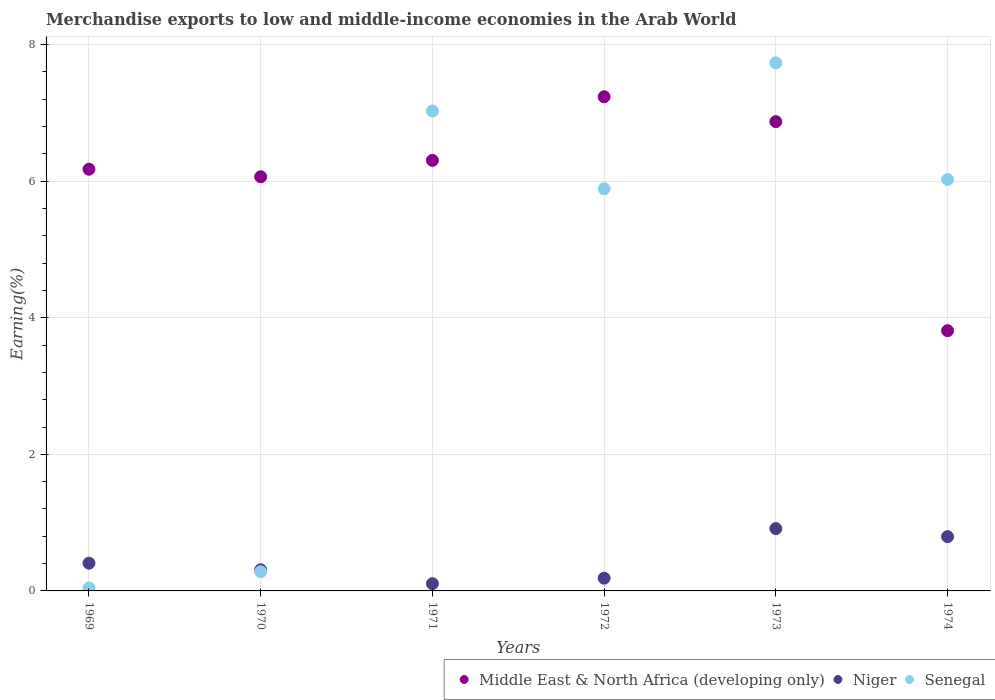What is the percentage of amount earned from merchandise exports in Niger in 1969?
Your response must be concise. 0.41. Across all years, what is the maximum percentage of amount earned from merchandise exports in Senegal?
Your answer should be compact. 7.73. Across all years, what is the minimum percentage of amount earned from merchandise exports in Niger?
Your answer should be very brief. 0.11. In which year was the percentage of amount earned from merchandise exports in Middle East & North Africa (developing only) minimum?
Provide a short and direct response. 1974. What is the total percentage of amount earned from merchandise exports in Senegal in the graph?
Your answer should be compact. 27. What is the difference between the percentage of amount earned from merchandise exports in Niger in 1969 and that in 1973?
Your response must be concise. -0.51. What is the difference between the percentage of amount earned from merchandise exports in Niger in 1972 and the percentage of amount earned from merchandise exports in Senegal in 1970?
Your answer should be very brief. -0.09. What is the average percentage of amount earned from merchandise exports in Middle East & North Africa (developing only) per year?
Provide a short and direct response. 6.08. In the year 1971, what is the difference between the percentage of amount earned from merchandise exports in Senegal and percentage of amount earned from merchandise exports in Niger?
Ensure brevity in your answer.  6.92. What is the ratio of the percentage of amount earned from merchandise exports in Senegal in 1970 to that in 1974?
Offer a very short reply. 0.05. Is the percentage of amount earned from merchandise exports in Senegal in 1970 less than that in 1974?
Keep it short and to the point. Yes. What is the difference between the highest and the second highest percentage of amount earned from merchandise exports in Senegal?
Offer a terse response. 0.71. What is the difference between the highest and the lowest percentage of amount earned from merchandise exports in Middle East & North Africa (developing only)?
Keep it short and to the point. 3.43. Is it the case that in every year, the sum of the percentage of amount earned from merchandise exports in Niger and percentage of amount earned from merchandise exports in Middle East & North Africa (developing only)  is greater than the percentage of amount earned from merchandise exports in Senegal?
Provide a succinct answer. No. Is the percentage of amount earned from merchandise exports in Senegal strictly less than the percentage of amount earned from merchandise exports in Niger over the years?
Ensure brevity in your answer.  No. What is the difference between two consecutive major ticks on the Y-axis?
Provide a succinct answer. 2. Where does the legend appear in the graph?
Ensure brevity in your answer.  Bottom right. How many legend labels are there?
Ensure brevity in your answer.  3. How are the legend labels stacked?
Keep it short and to the point. Horizontal. What is the title of the graph?
Your answer should be very brief. Merchandise exports to low and middle-income economies in the Arab World. Does "Moldova" appear as one of the legend labels in the graph?
Provide a succinct answer. No. What is the label or title of the Y-axis?
Provide a succinct answer. Earning(%). What is the Earning(%) of Middle East & North Africa (developing only) in 1969?
Provide a succinct answer. 6.18. What is the Earning(%) in Niger in 1969?
Ensure brevity in your answer.  0.41. What is the Earning(%) of Senegal in 1969?
Your response must be concise. 0.04. What is the Earning(%) of Middle East & North Africa (developing only) in 1970?
Offer a terse response. 6.06. What is the Earning(%) in Niger in 1970?
Provide a succinct answer. 0.31. What is the Earning(%) of Senegal in 1970?
Your answer should be very brief. 0.28. What is the Earning(%) in Middle East & North Africa (developing only) in 1971?
Provide a succinct answer. 6.3. What is the Earning(%) of Niger in 1971?
Offer a very short reply. 0.11. What is the Earning(%) of Senegal in 1971?
Offer a terse response. 7.03. What is the Earning(%) of Middle East & North Africa (developing only) in 1972?
Make the answer very short. 7.24. What is the Earning(%) in Niger in 1972?
Make the answer very short. 0.19. What is the Earning(%) in Senegal in 1972?
Provide a short and direct response. 5.89. What is the Earning(%) in Middle East & North Africa (developing only) in 1973?
Give a very brief answer. 6.87. What is the Earning(%) of Niger in 1973?
Your answer should be compact. 0.91. What is the Earning(%) of Senegal in 1973?
Give a very brief answer. 7.73. What is the Earning(%) in Middle East & North Africa (developing only) in 1974?
Offer a terse response. 3.81. What is the Earning(%) of Niger in 1974?
Your answer should be compact. 0.79. What is the Earning(%) in Senegal in 1974?
Make the answer very short. 6.02. Across all years, what is the maximum Earning(%) in Middle East & North Africa (developing only)?
Your answer should be very brief. 7.24. Across all years, what is the maximum Earning(%) in Niger?
Keep it short and to the point. 0.91. Across all years, what is the maximum Earning(%) in Senegal?
Provide a succinct answer. 7.73. Across all years, what is the minimum Earning(%) in Middle East & North Africa (developing only)?
Offer a terse response. 3.81. Across all years, what is the minimum Earning(%) of Niger?
Your response must be concise. 0.11. Across all years, what is the minimum Earning(%) of Senegal?
Make the answer very short. 0.04. What is the total Earning(%) of Middle East & North Africa (developing only) in the graph?
Your answer should be very brief. 36.46. What is the total Earning(%) of Niger in the graph?
Keep it short and to the point. 2.72. What is the total Earning(%) of Senegal in the graph?
Ensure brevity in your answer.  27. What is the difference between the Earning(%) of Middle East & North Africa (developing only) in 1969 and that in 1970?
Offer a terse response. 0.11. What is the difference between the Earning(%) in Niger in 1969 and that in 1970?
Offer a very short reply. 0.1. What is the difference between the Earning(%) of Senegal in 1969 and that in 1970?
Provide a succinct answer. -0.24. What is the difference between the Earning(%) of Middle East & North Africa (developing only) in 1969 and that in 1971?
Give a very brief answer. -0.13. What is the difference between the Earning(%) of Niger in 1969 and that in 1971?
Your answer should be compact. 0.3. What is the difference between the Earning(%) in Senegal in 1969 and that in 1971?
Make the answer very short. -6.98. What is the difference between the Earning(%) of Middle East & North Africa (developing only) in 1969 and that in 1972?
Your response must be concise. -1.06. What is the difference between the Earning(%) in Niger in 1969 and that in 1972?
Offer a terse response. 0.22. What is the difference between the Earning(%) of Senegal in 1969 and that in 1972?
Offer a very short reply. -5.85. What is the difference between the Earning(%) in Middle East & North Africa (developing only) in 1969 and that in 1973?
Ensure brevity in your answer.  -0.7. What is the difference between the Earning(%) in Niger in 1969 and that in 1973?
Provide a succinct answer. -0.51. What is the difference between the Earning(%) of Senegal in 1969 and that in 1973?
Make the answer very short. -7.69. What is the difference between the Earning(%) of Middle East & North Africa (developing only) in 1969 and that in 1974?
Provide a succinct answer. 2.36. What is the difference between the Earning(%) in Niger in 1969 and that in 1974?
Provide a succinct answer. -0.39. What is the difference between the Earning(%) in Senegal in 1969 and that in 1974?
Your response must be concise. -5.98. What is the difference between the Earning(%) of Middle East & North Africa (developing only) in 1970 and that in 1971?
Provide a short and direct response. -0.24. What is the difference between the Earning(%) in Niger in 1970 and that in 1971?
Offer a very short reply. 0.2. What is the difference between the Earning(%) of Senegal in 1970 and that in 1971?
Ensure brevity in your answer.  -6.75. What is the difference between the Earning(%) in Middle East & North Africa (developing only) in 1970 and that in 1972?
Offer a very short reply. -1.17. What is the difference between the Earning(%) in Niger in 1970 and that in 1972?
Your answer should be very brief. 0.12. What is the difference between the Earning(%) in Senegal in 1970 and that in 1972?
Offer a very short reply. -5.61. What is the difference between the Earning(%) in Middle East & North Africa (developing only) in 1970 and that in 1973?
Give a very brief answer. -0.81. What is the difference between the Earning(%) of Niger in 1970 and that in 1973?
Provide a short and direct response. -0.6. What is the difference between the Earning(%) in Senegal in 1970 and that in 1973?
Your answer should be compact. -7.45. What is the difference between the Earning(%) of Middle East & North Africa (developing only) in 1970 and that in 1974?
Ensure brevity in your answer.  2.25. What is the difference between the Earning(%) of Niger in 1970 and that in 1974?
Offer a very short reply. -0.48. What is the difference between the Earning(%) in Senegal in 1970 and that in 1974?
Provide a succinct answer. -5.74. What is the difference between the Earning(%) of Middle East & North Africa (developing only) in 1971 and that in 1972?
Offer a very short reply. -0.93. What is the difference between the Earning(%) in Niger in 1971 and that in 1972?
Your answer should be very brief. -0.08. What is the difference between the Earning(%) of Senegal in 1971 and that in 1972?
Provide a short and direct response. 1.14. What is the difference between the Earning(%) of Middle East & North Africa (developing only) in 1971 and that in 1973?
Provide a short and direct response. -0.57. What is the difference between the Earning(%) in Niger in 1971 and that in 1973?
Make the answer very short. -0.81. What is the difference between the Earning(%) of Senegal in 1971 and that in 1973?
Make the answer very short. -0.71. What is the difference between the Earning(%) in Middle East & North Africa (developing only) in 1971 and that in 1974?
Provide a short and direct response. 2.49. What is the difference between the Earning(%) of Niger in 1971 and that in 1974?
Keep it short and to the point. -0.69. What is the difference between the Earning(%) of Middle East & North Africa (developing only) in 1972 and that in 1973?
Provide a short and direct response. 0.36. What is the difference between the Earning(%) in Niger in 1972 and that in 1973?
Provide a succinct answer. -0.73. What is the difference between the Earning(%) in Senegal in 1972 and that in 1973?
Ensure brevity in your answer.  -1.84. What is the difference between the Earning(%) in Middle East & North Africa (developing only) in 1972 and that in 1974?
Your answer should be very brief. 3.43. What is the difference between the Earning(%) in Niger in 1972 and that in 1974?
Keep it short and to the point. -0.61. What is the difference between the Earning(%) of Senegal in 1972 and that in 1974?
Provide a succinct answer. -0.14. What is the difference between the Earning(%) in Middle East & North Africa (developing only) in 1973 and that in 1974?
Keep it short and to the point. 3.06. What is the difference between the Earning(%) of Niger in 1973 and that in 1974?
Provide a short and direct response. 0.12. What is the difference between the Earning(%) of Senegal in 1973 and that in 1974?
Your response must be concise. 1.71. What is the difference between the Earning(%) in Middle East & North Africa (developing only) in 1969 and the Earning(%) in Niger in 1970?
Give a very brief answer. 5.87. What is the difference between the Earning(%) in Middle East & North Africa (developing only) in 1969 and the Earning(%) in Senegal in 1970?
Provide a succinct answer. 5.89. What is the difference between the Earning(%) of Niger in 1969 and the Earning(%) of Senegal in 1970?
Provide a succinct answer. 0.13. What is the difference between the Earning(%) of Middle East & North Africa (developing only) in 1969 and the Earning(%) of Niger in 1971?
Keep it short and to the point. 6.07. What is the difference between the Earning(%) of Middle East & North Africa (developing only) in 1969 and the Earning(%) of Senegal in 1971?
Offer a very short reply. -0.85. What is the difference between the Earning(%) in Niger in 1969 and the Earning(%) in Senegal in 1971?
Your answer should be very brief. -6.62. What is the difference between the Earning(%) of Middle East & North Africa (developing only) in 1969 and the Earning(%) of Niger in 1972?
Provide a succinct answer. 5.99. What is the difference between the Earning(%) in Middle East & North Africa (developing only) in 1969 and the Earning(%) in Senegal in 1972?
Provide a succinct answer. 0.29. What is the difference between the Earning(%) of Niger in 1969 and the Earning(%) of Senegal in 1972?
Offer a very short reply. -5.48. What is the difference between the Earning(%) of Middle East & North Africa (developing only) in 1969 and the Earning(%) of Niger in 1973?
Your answer should be compact. 5.26. What is the difference between the Earning(%) in Middle East & North Africa (developing only) in 1969 and the Earning(%) in Senegal in 1973?
Your response must be concise. -1.56. What is the difference between the Earning(%) of Niger in 1969 and the Earning(%) of Senegal in 1973?
Your response must be concise. -7.33. What is the difference between the Earning(%) of Middle East & North Africa (developing only) in 1969 and the Earning(%) of Niger in 1974?
Offer a very short reply. 5.38. What is the difference between the Earning(%) of Middle East & North Africa (developing only) in 1969 and the Earning(%) of Senegal in 1974?
Keep it short and to the point. 0.15. What is the difference between the Earning(%) of Niger in 1969 and the Earning(%) of Senegal in 1974?
Keep it short and to the point. -5.62. What is the difference between the Earning(%) in Middle East & North Africa (developing only) in 1970 and the Earning(%) in Niger in 1971?
Your response must be concise. 5.96. What is the difference between the Earning(%) in Middle East & North Africa (developing only) in 1970 and the Earning(%) in Senegal in 1971?
Provide a short and direct response. -0.96. What is the difference between the Earning(%) of Niger in 1970 and the Earning(%) of Senegal in 1971?
Provide a succinct answer. -6.72. What is the difference between the Earning(%) of Middle East & North Africa (developing only) in 1970 and the Earning(%) of Niger in 1972?
Offer a terse response. 5.88. What is the difference between the Earning(%) of Middle East & North Africa (developing only) in 1970 and the Earning(%) of Senegal in 1972?
Give a very brief answer. 0.18. What is the difference between the Earning(%) in Niger in 1970 and the Earning(%) in Senegal in 1972?
Your response must be concise. -5.58. What is the difference between the Earning(%) in Middle East & North Africa (developing only) in 1970 and the Earning(%) in Niger in 1973?
Keep it short and to the point. 5.15. What is the difference between the Earning(%) in Middle East & North Africa (developing only) in 1970 and the Earning(%) in Senegal in 1973?
Your answer should be compact. -1.67. What is the difference between the Earning(%) of Niger in 1970 and the Earning(%) of Senegal in 1973?
Give a very brief answer. -7.42. What is the difference between the Earning(%) in Middle East & North Africa (developing only) in 1970 and the Earning(%) in Niger in 1974?
Offer a terse response. 5.27. What is the difference between the Earning(%) of Middle East & North Africa (developing only) in 1970 and the Earning(%) of Senegal in 1974?
Your response must be concise. 0.04. What is the difference between the Earning(%) in Niger in 1970 and the Earning(%) in Senegal in 1974?
Provide a succinct answer. -5.72. What is the difference between the Earning(%) in Middle East & North Africa (developing only) in 1971 and the Earning(%) in Niger in 1972?
Your answer should be compact. 6.12. What is the difference between the Earning(%) of Middle East & North Africa (developing only) in 1971 and the Earning(%) of Senegal in 1972?
Offer a terse response. 0.42. What is the difference between the Earning(%) of Niger in 1971 and the Earning(%) of Senegal in 1972?
Provide a short and direct response. -5.78. What is the difference between the Earning(%) of Middle East & North Africa (developing only) in 1971 and the Earning(%) of Niger in 1973?
Provide a short and direct response. 5.39. What is the difference between the Earning(%) in Middle East & North Africa (developing only) in 1971 and the Earning(%) in Senegal in 1973?
Keep it short and to the point. -1.43. What is the difference between the Earning(%) in Niger in 1971 and the Earning(%) in Senegal in 1973?
Your response must be concise. -7.63. What is the difference between the Earning(%) of Middle East & North Africa (developing only) in 1971 and the Earning(%) of Niger in 1974?
Offer a terse response. 5.51. What is the difference between the Earning(%) in Middle East & North Africa (developing only) in 1971 and the Earning(%) in Senegal in 1974?
Provide a short and direct response. 0.28. What is the difference between the Earning(%) in Niger in 1971 and the Earning(%) in Senegal in 1974?
Give a very brief answer. -5.92. What is the difference between the Earning(%) in Middle East & North Africa (developing only) in 1972 and the Earning(%) in Niger in 1973?
Your answer should be very brief. 6.32. What is the difference between the Earning(%) in Middle East & North Africa (developing only) in 1972 and the Earning(%) in Senegal in 1973?
Provide a succinct answer. -0.5. What is the difference between the Earning(%) in Niger in 1972 and the Earning(%) in Senegal in 1973?
Offer a very short reply. -7.55. What is the difference between the Earning(%) of Middle East & North Africa (developing only) in 1972 and the Earning(%) of Niger in 1974?
Make the answer very short. 6.44. What is the difference between the Earning(%) in Middle East & North Africa (developing only) in 1972 and the Earning(%) in Senegal in 1974?
Your answer should be very brief. 1.21. What is the difference between the Earning(%) in Niger in 1972 and the Earning(%) in Senegal in 1974?
Ensure brevity in your answer.  -5.84. What is the difference between the Earning(%) in Middle East & North Africa (developing only) in 1973 and the Earning(%) in Niger in 1974?
Offer a terse response. 6.08. What is the difference between the Earning(%) of Middle East & North Africa (developing only) in 1973 and the Earning(%) of Senegal in 1974?
Your answer should be very brief. 0.85. What is the difference between the Earning(%) in Niger in 1973 and the Earning(%) in Senegal in 1974?
Provide a succinct answer. -5.11. What is the average Earning(%) in Middle East & North Africa (developing only) per year?
Ensure brevity in your answer.  6.08. What is the average Earning(%) in Niger per year?
Your response must be concise. 0.45. In the year 1969, what is the difference between the Earning(%) of Middle East & North Africa (developing only) and Earning(%) of Niger?
Your answer should be very brief. 5.77. In the year 1969, what is the difference between the Earning(%) in Middle East & North Africa (developing only) and Earning(%) in Senegal?
Your answer should be very brief. 6.13. In the year 1969, what is the difference between the Earning(%) of Niger and Earning(%) of Senegal?
Provide a succinct answer. 0.36. In the year 1970, what is the difference between the Earning(%) in Middle East & North Africa (developing only) and Earning(%) in Niger?
Your answer should be compact. 5.76. In the year 1970, what is the difference between the Earning(%) in Middle East & North Africa (developing only) and Earning(%) in Senegal?
Provide a short and direct response. 5.78. In the year 1970, what is the difference between the Earning(%) of Niger and Earning(%) of Senegal?
Keep it short and to the point. 0.03. In the year 1971, what is the difference between the Earning(%) in Middle East & North Africa (developing only) and Earning(%) in Niger?
Provide a short and direct response. 6.2. In the year 1971, what is the difference between the Earning(%) of Middle East & North Africa (developing only) and Earning(%) of Senegal?
Offer a terse response. -0.72. In the year 1971, what is the difference between the Earning(%) of Niger and Earning(%) of Senegal?
Provide a short and direct response. -6.92. In the year 1972, what is the difference between the Earning(%) in Middle East & North Africa (developing only) and Earning(%) in Niger?
Make the answer very short. 7.05. In the year 1972, what is the difference between the Earning(%) of Middle East & North Africa (developing only) and Earning(%) of Senegal?
Your response must be concise. 1.35. In the year 1972, what is the difference between the Earning(%) of Niger and Earning(%) of Senegal?
Your answer should be very brief. -5.7. In the year 1973, what is the difference between the Earning(%) in Middle East & North Africa (developing only) and Earning(%) in Niger?
Your answer should be very brief. 5.96. In the year 1973, what is the difference between the Earning(%) of Middle East & North Africa (developing only) and Earning(%) of Senegal?
Provide a short and direct response. -0.86. In the year 1973, what is the difference between the Earning(%) in Niger and Earning(%) in Senegal?
Provide a succinct answer. -6.82. In the year 1974, what is the difference between the Earning(%) of Middle East & North Africa (developing only) and Earning(%) of Niger?
Keep it short and to the point. 3.02. In the year 1974, what is the difference between the Earning(%) in Middle East & North Africa (developing only) and Earning(%) in Senegal?
Provide a succinct answer. -2.21. In the year 1974, what is the difference between the Earning(%) in Niger and Earning(%) in Senegal?
Keep it short and to the point. -5.23. What is the ratio of the Earning(%) of Middle East & North Africa (developing only) in 1969 to that in 1970?
Your response must be concise. 1.02. What is the ratio of the Earning(%) in Niger in 1969 to that in 1970?
Your answer should be compact. 1.31. What is the ratio of the Earning(%) of Senegal in 1969 to that in 1970?
Your response must be concise. 0.16. What is the ratio of the Earning(%) in Middle East & North Africa (developing only) in 1969 to that in 1971?
Provide a short and direct response. 0.98. What is the ratio of the Earning(%) of Niger in 1969 to that in 1971?
Make the answer very short. 3.81. What is the ratio of the Earning(%) in Senegal in 1969 to that in 1971?
Provide a short and direct response. 0.01. What is the ratio of the Earning(%) in Middle East & North Africa (developing only) in 1969 to that in 1972?
Keep it short and to the point. 0.85. What is the ratio of the Earning(%) of Niger in 1969 to that in 1972?
Offer a very short reply. 2.18. What is the ratio of the Earning(%) of Senegal in 1969 to that in 1972?
Make the answer very short. 0.01. What is the ratio of the Earning(%) in Middle East & North Africa (developing only) in 1969 to that in 1973?
Keep it short and to the point. 0.9. What is the ratio of the Earning(%) of Niger in 1969 to that in 1973?
Offer a very short reply. 0.45. What is the ratio of the Earning(%) of Senegal in 1969 to that in 1973?
Offer a very short reply. 0.01. What is the ratio of the Earning(%) in Middle East & North Africa (developing only) in 1969 to that in 1974?
Your answer should be very brief. 1.62. What is the ratio of the Earning(%) of Niger in 1969 to that in 1974?
Your answer should be very brief. 0.51. What is the ratio of the Earning(%) of Senegal in 1969 to that in 1974?
Provide a short and direct response. 0.01. What is the ratio of the Earning(%) in Middle East & North Africa (developing only) in 1970 to that in 1971?
Your answer should be compact. 0.96. What is the ratio of the Earning(%) of Niger in 1970 to that in 1971?
Your answer should be compact. 2.9. What is the ratio of the Earning(%) in Senegal in 1970 to that in 1971?
Offer a terse response. 0.04. What is the ratio of the Earning(%) of Middle East & North Africa (developing only) in 1970 to that in 1972?
Offer a very short reply. 0.84. What is the ratio of the Earning(%) of Niger in 1970 to that in 1972?
Your answer should be compact. 1.66. What is the ratio of the Earning(%) in Senegal in 1970 to that in 1972?
Your response must be concise. 0.05. What is the ratio of the Earning(%) of Middle East & North Africa (developing only) in 1970 to that in 1973?
Your answer should be compact. 0.88. What is the ratio of the Earning(%) of Niger in 1970 to that in 1973?
Your answer should be compact. 0.34. What is the ratio of the Earning(%) in Senegal in 1970 to that in 1973?
Offer a terse response. 0.04. What is the ratio of the Earning(%) in Middle East & North Africa (developing only) in 1970 to that in 1974?
Provide a succinct answer. 1.59. What is the ratio of the Earning(%) of Niger in 1970 to that in 1974?
Ensure brevity in your answer.  0.39. What is the ratio of the Earning(%) of Senegal in 1970 to that in 1974?
Make the answer very short. 0.05. What is the ratio of the Earning(%) of Middle East & North Africa (developing only) in 1971 to that in 1972?
Make the answer very short. 0.87. What is the ratio of the Earning(%) of Niger in 1971 to that in 1972?
Your answer should be very brief. 0.57. What is the ratio of the Earning(%) in Senegal in 1971 to that in 1972?
Ensure brevity in your answer.  1.19. What is the ratio of the Earning(%) in Middle East & North Africa (developing only) in 1971 to that in 1973?
Make the answer very short. 0.92. What is the ratio of the Earning(%) in Niger in 1971 to that in 1973?
Make the answer very short. 0.12. What is the ratio of the Earning(%) in Senegal in 1971 to that in 1973?
Provide a short and direct response. 0.91. What is the ratio of the Earning(%) in Middle East & North Africa (developing only) in 1971 to that in 1974?
Make the answer very short. 1.65. What is the ratio of the Earning(%) of Niger in 1971 to that in 1974?
Provide a short and direct response. 0.13. What is the ratio of the Earning(%) in Senegal in 1971 to that in 1974?
Give a very brief answer. 1.17. What is the ratio of the Earning(%) of Middle East & North Africa (developing only) in 1972 to that in 1973?
Your answer should be compact. 1.05. What is the ratio of the Earning(%) of Niger in 1972 to that in 1973?
Your answer should be compact. 0.2. What is the ratio of the Earning(%) in Senegal in 1972 to that in 1973?
Make the answer very short. 0.76. What is the ratio of the Earning(%) in Middle East & North Africa (developing only) in 1972 to that in 1974?
Offer a very short reply. 1.9. What is the ratio of the Earning(%) of Niger in 1972 to that in 1974?
Give a very brief answer. 0.23. What is the ratio of the Earning(%) of Senegal in 1972 to that in 1974?
Your response must be concise. 0.98. What is the ratio of the Earning(%) of Middle East & North Africa (developing only) in 1973 to that in 1974?
Your answer should be compact. 1.8. What is the ratio of the Earning(%) of Niger in 1973 to that in 1974?
Provide a succinct answer. 1.15. What is the ratio of the Earning(%) in Senegal in 1973 to that in 1974?
Offer a very short reply. 1.28. What is the difference between the highest and the second highest Earning(%) in Middle East & North Africa (developing only)?
Provide a short and direct response. 0.36. What is the difference between the highest and the second highest Earning(%) in Niger?
Offer a terse response. 0.12. What is the difference between the highest and the second highest Earning(%) of Senegal?
Ensure brevity in your answer.  0.71. What is the difference between the highest and the lowest Earning(%) in Middle East & North Africa (developing only)?
Provide a succinct answer. 3.43. What is the difference between the highest and the lowest Earning(%) in Niger?
Your answer should be compact. 0.81. What is the difference between the highest and the lowest Earning(%) of Senegal?
Your answer should be very brief. 7.69. 